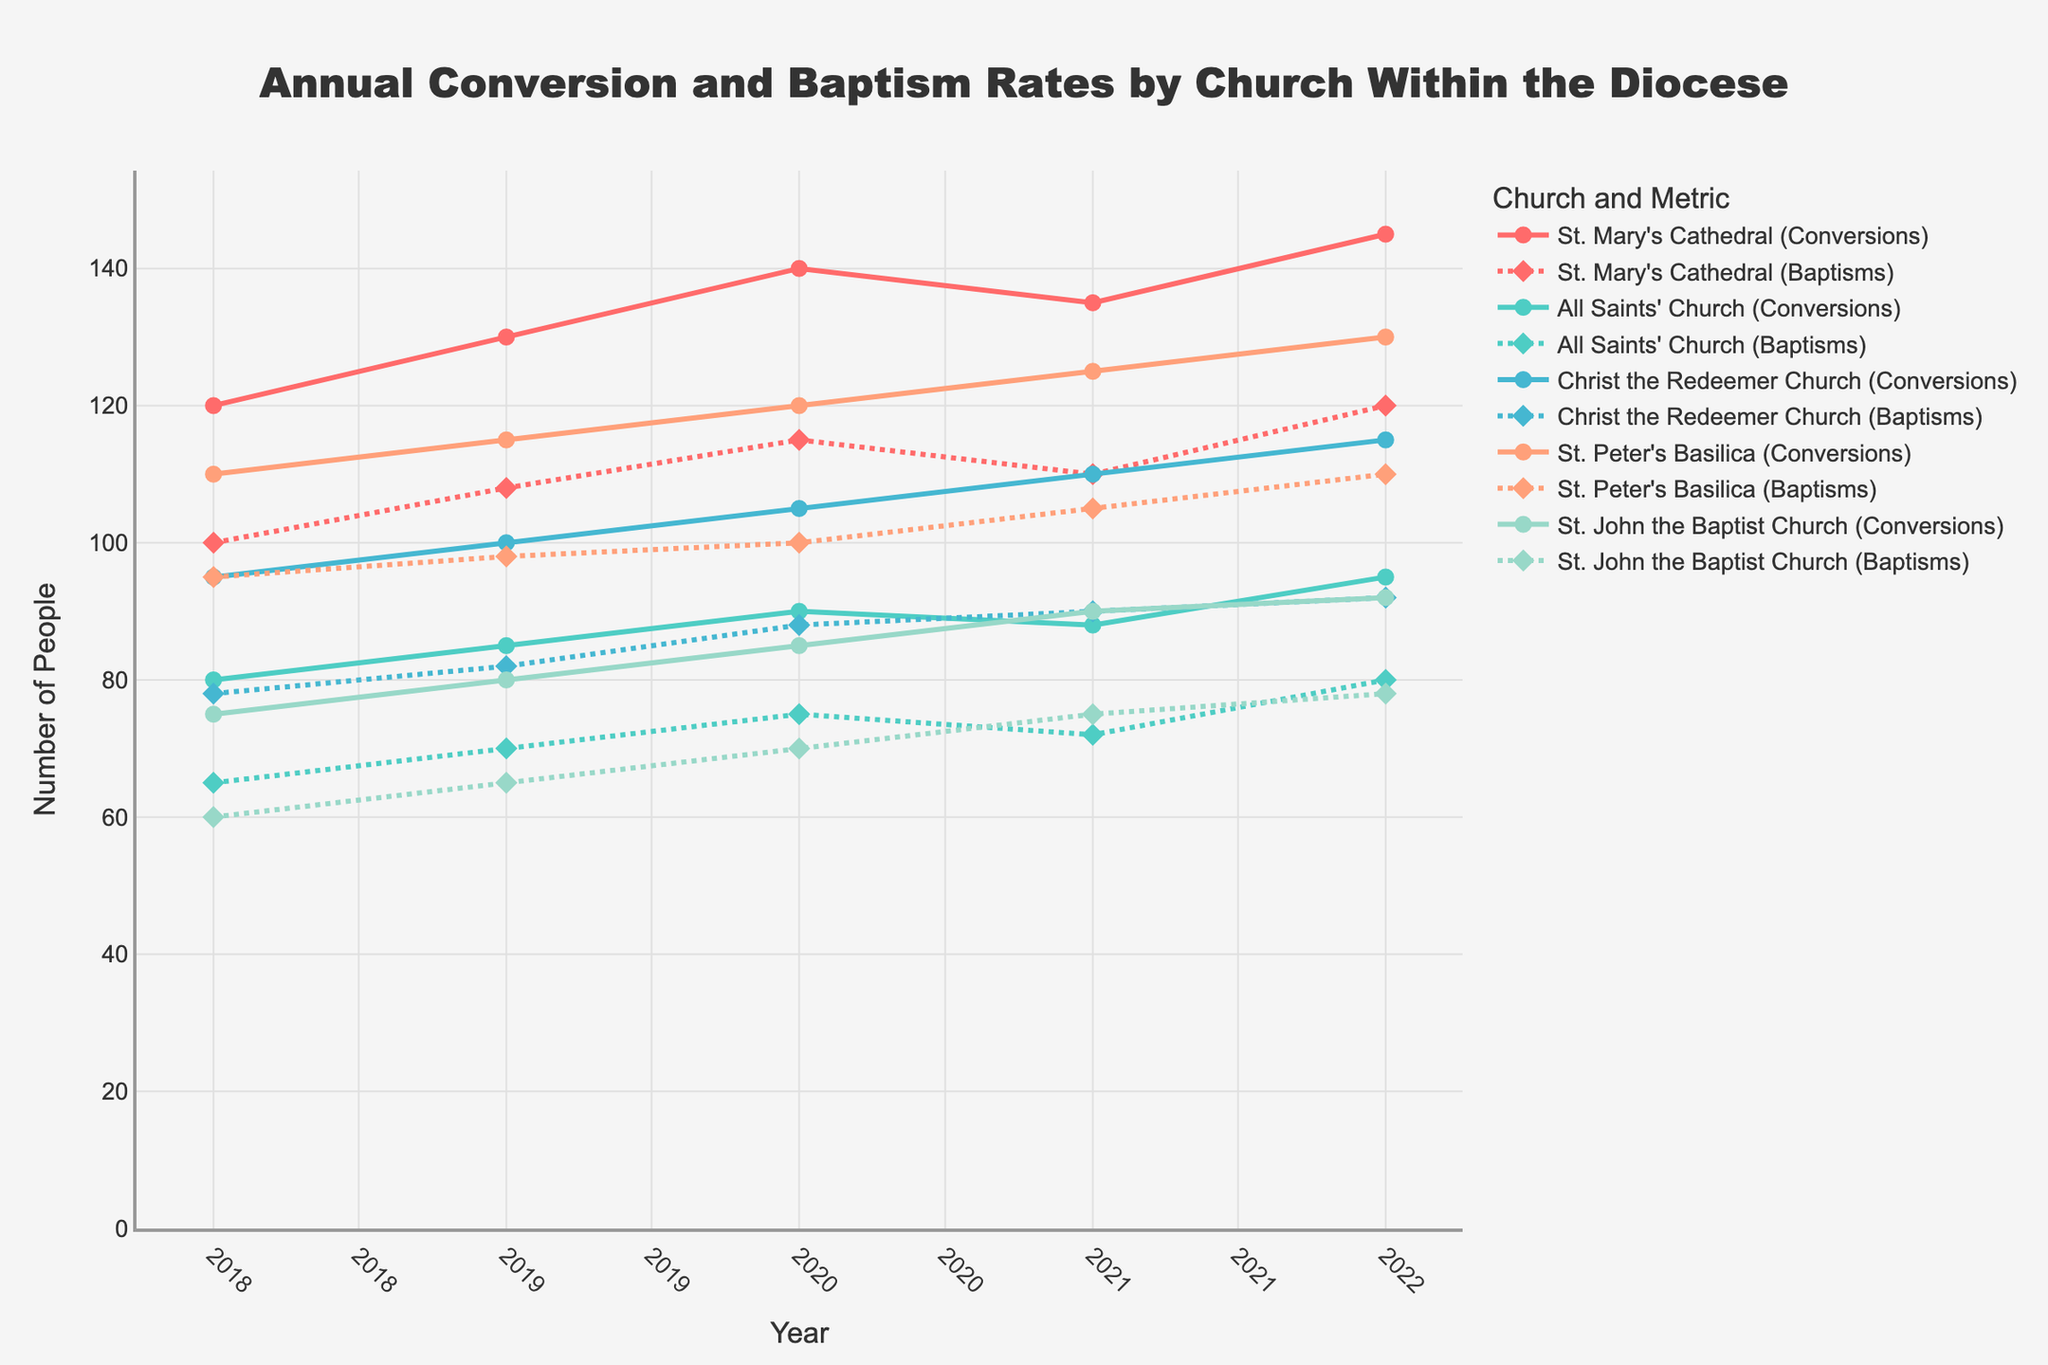What is the title of the figure? The title is typically displayed at the top of the figure and is central to understanding its content.
Answer: Annual Conversion and Baptism Rates by Church Within the Diocese Which church had the highest number of conversions in 2022? Identify the highest data point for conversions (solid lines with circle markers) in the year 2022.
Answer: St. Mary's Cathedral How many churches are represented in the figure? Count the number of unique line colors, each representing a different church.
Answer: Five What is the trend in conversions for St. Mary's Cathedral from 2018 to 2022? Observe the solid line with circle markers for St. Mary's Cathedral; note whether it increases, decreases, or remains stable over the years.
Answer: Increasing Compare the baptism rates of All Saints’ Church and St. John the Baptist Church in 2020. Which one had a higher number? Look for the dotted lines with diamond markers for both churches in the year 2020 and compare their heights.
Answer: All Saints’ Church What was the overall trend in baptisms across all churches from 2018 to 2022? Examine the dotted lines with diamond markers for all churches over the years; note whether there's an upward, downward, or stable general trend.
Answer: Increasing Between 2019 and 2020, how much did the number of conversions at Christ the Redeemer Church increase? Subtract the number of conversions in 2019 from the number in 2020 for Christ the Redeemer Church.
Answer: 5 Which church had the smallest increase in conversions from 2018 to 2022? Calculate the increase for each church by subtracting the 2018 data from the 2022 data for conversions; identify the smallest increase.
Answer: All Saints' Church How do the trends of conversions and baptisms compare for St. Peter’s Basilica? Observe the solid line with circle markers (conversions) and the dotted line with diamond markers (baptisms) for St. Peter’s Basilica and compare their directions over the years.
Answer: Both increasing, conversions slightly more consistent Among all the churches, which had the most consistent baptism rates from 2018 to 2022? Check the dotted lines with diamond markers for all churches and identify the line that shows the least fluctuation over the years.
Answer: St. Peter's Basilica 